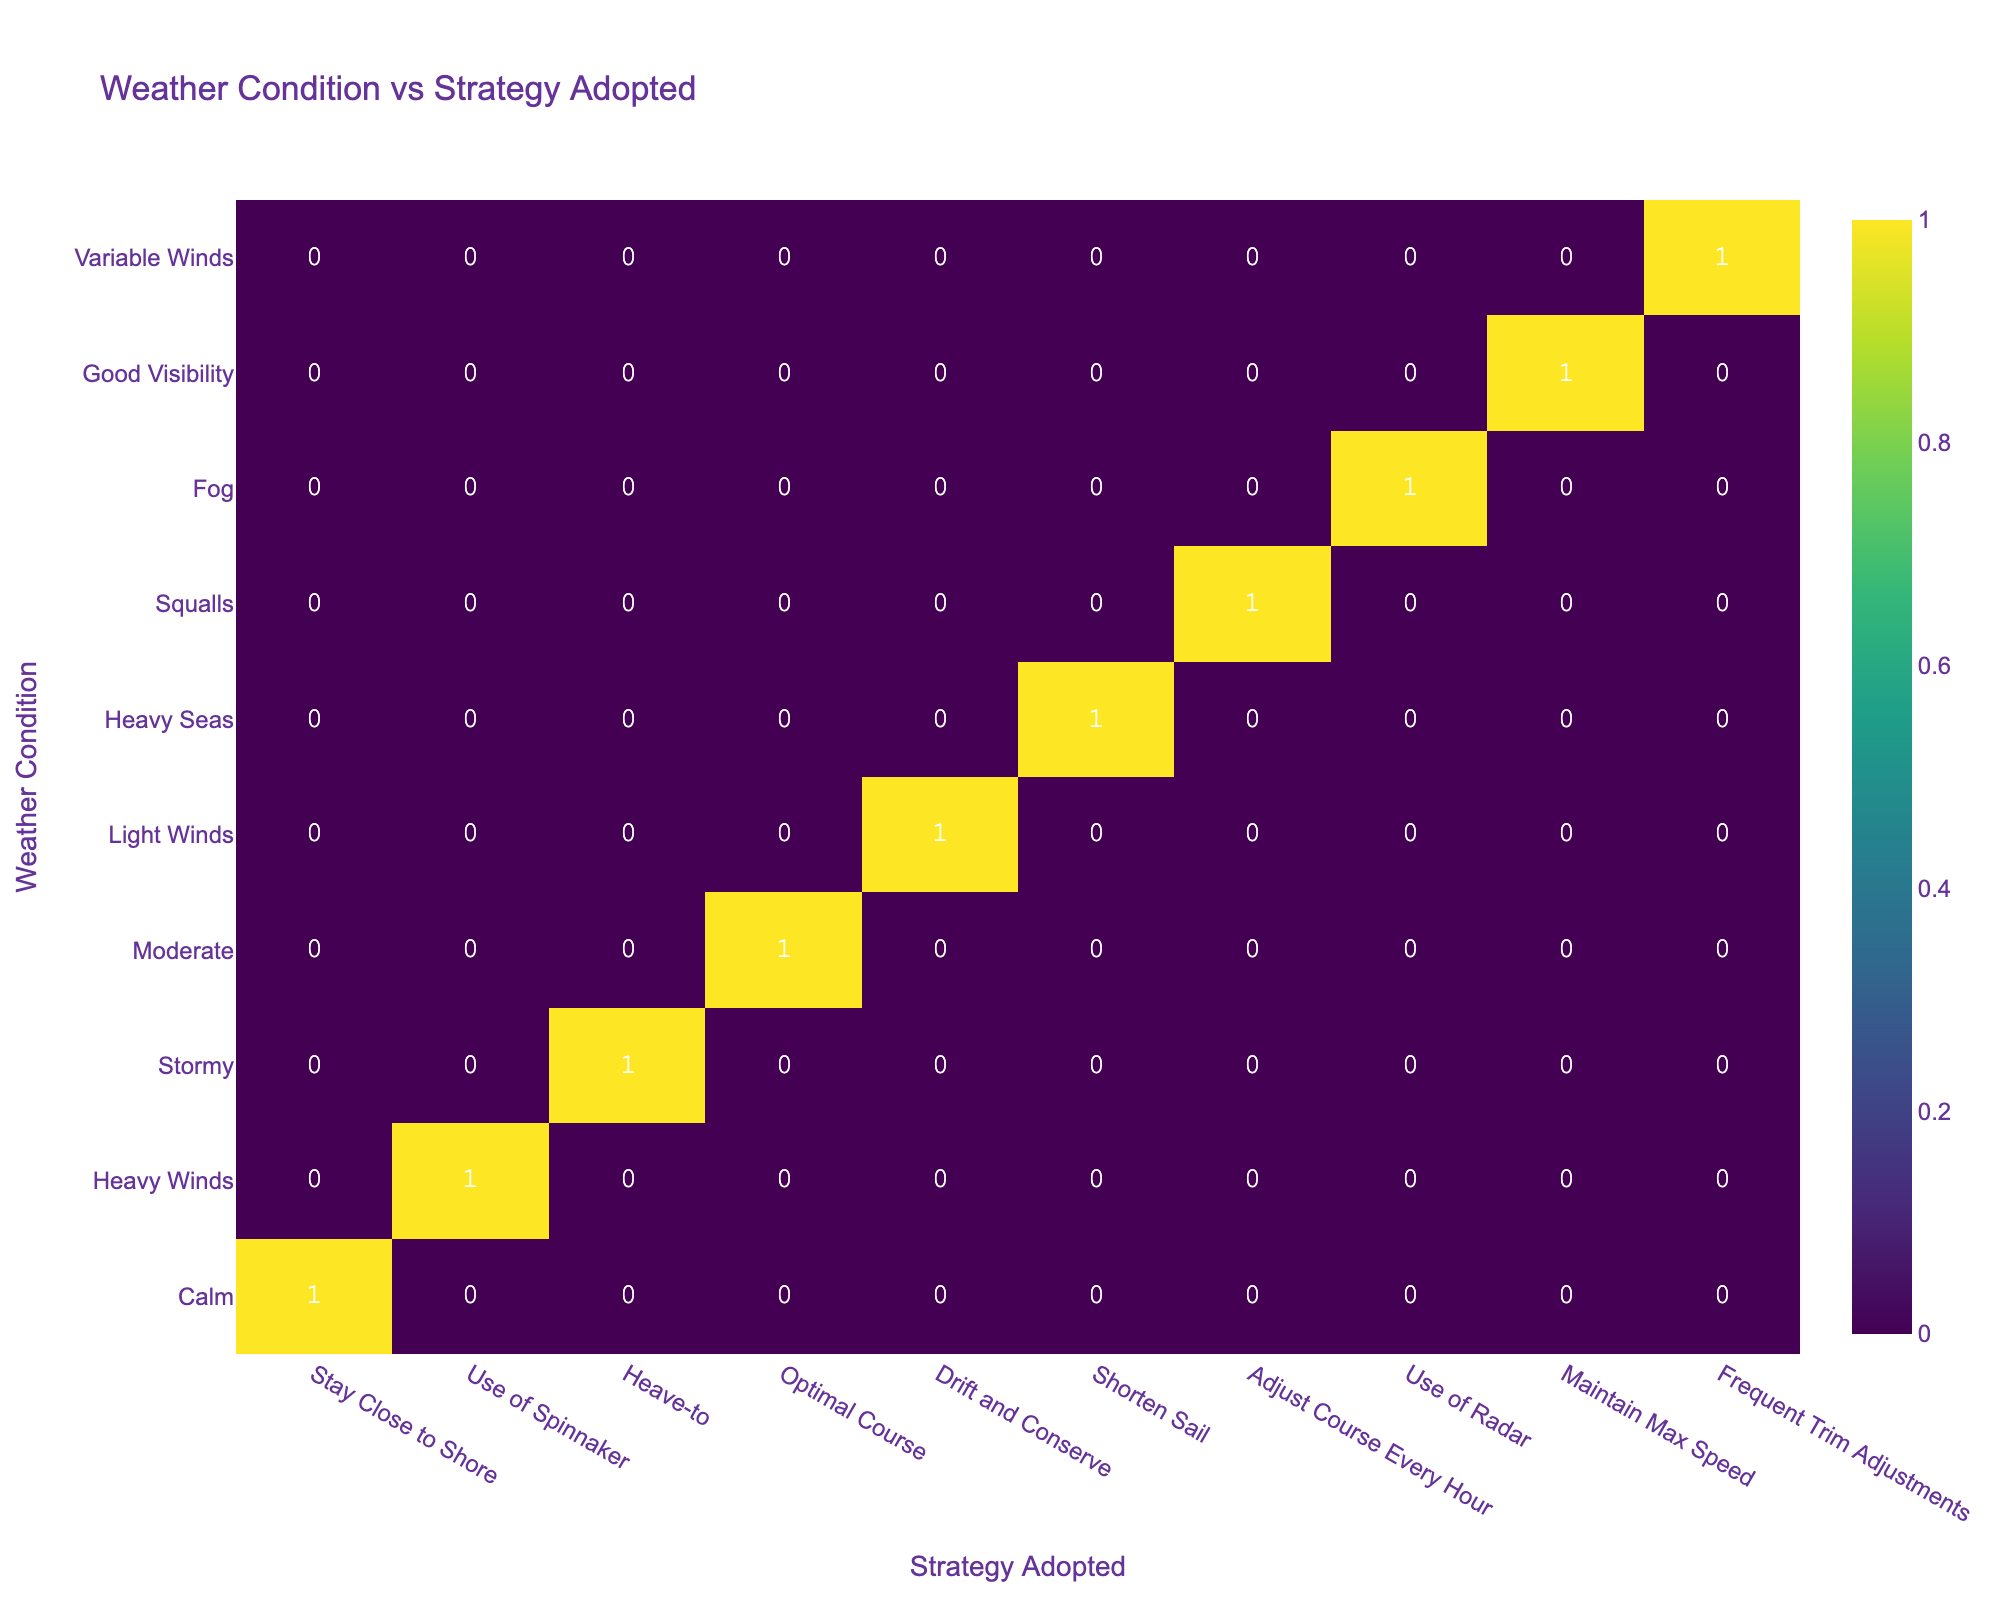What is the total number of strategies adopted during calm weather? From the table, under the "Calm" weather condition, only one strategy is recorded: "Stay Close to Shore," which has a count of 1. Thus, the total number of strategies adopted during calm weather is simply the sum of this count.
Answer: 1 Which strategy was most frequently adopted in heavy winds? In the "Heavy Winds" category, two strategies are listed: "Use of Spinnaker" and "Shorten Sail." However, only "Use of Spinnaker" is associated with a count of 1, thus there are no repetitions. Therefore, this strategy is the most frequently adopted in heavy winds.
Answer: Use of Spinnaker Did Arnaud Boissières succeed under moderate weather conditions? In the table, it shows that under "Moderate" weather, Arnaud Boissières adopted the strategy "Optimal Course" and the result is "Success." Hence, the answer to the question is confirmed through the data.
Answer: Yes How many strategies resulted in success when conditions were stormy? For "Stormy" conditions, only one strategy is recorded: "Heave-to," which resulted in a "Failure." Therefore, there are no strategies that yielded success under stormy conditions.
Answer: 0 What is the count of strategies adopted that had a successful outcome? The successful outcomes are under calm (1), heavy winds (1), moderate (1), squalls (1), good visibility (1), and variable winds (1). Summing these gives us a total of six strategies resulting in success.
Answer: 6 Was there any instance of a sailor adopting a strategy for foggy conditions? The table indicates that in "Fog" conditions, the strategy "Use of Radar" was adopted, with a result of "Failure." This confirms that at least one instance exists where a strategy was adopted for foggy conditions.
Answer: Yes Which strategy had the highest number of successful outcomes compared to others? By analyzing each strategy's success record through the data, "Adjust Course Every Hour" under "Squalls," along with others, leads to the conclusion. The strategy "Staying Close to Shore" is the only unique one but is a single instance, while multiple strategies yield 1 success. Thus, no one strategy surpasses others in successful outcomes overall.
Answer: No single strategy stands out 